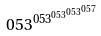Convert formula to latex. <formula><loc_0><loc_0><loc_500><loc_500>0 5 3 ^ { 0 5 3 ^ { 0 5 3 ^ { 0 5 3 ^ { 0 5 7 } } } }</formula> 